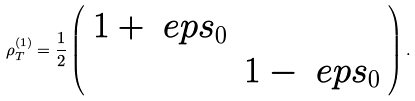Convert formula to latex. <formula><loc_0><loc_0><loc_500><loc_500>\rho _ { T } ^ { ( 1 ) } = \frac { 1 } { 2 } \left ( \begin{array} { c c } 1 + \ e p s _ { 0 } & \\ & 1 - \ e p s _ { 0 } \end{array} \right ) .</formula> 